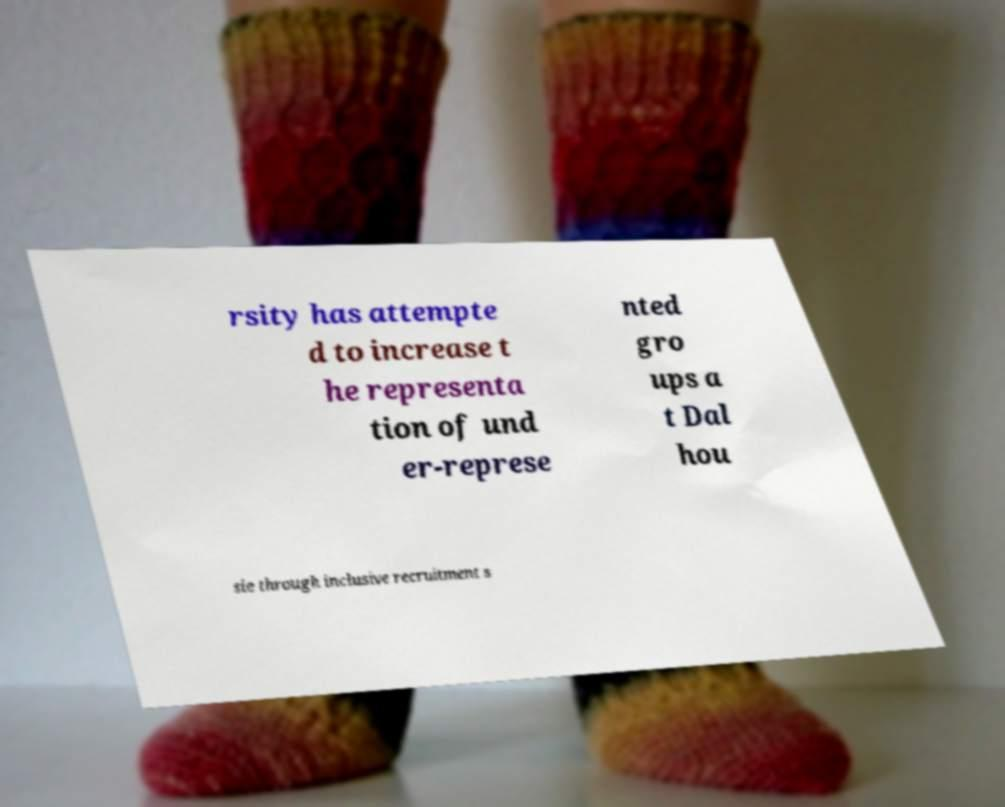Can you read and provide the text displayed in the image?This photo seems to have some interesting text. Can you extract and type it out for me? rsity has attempte d to increase t he representa tion of und er-represe nted gro ups a t Dal hou sie through inclusive recruitment s 